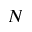Convert formula to latex. <formula><loc_0><loc_0><loc_500><loc_500>N</formula> 